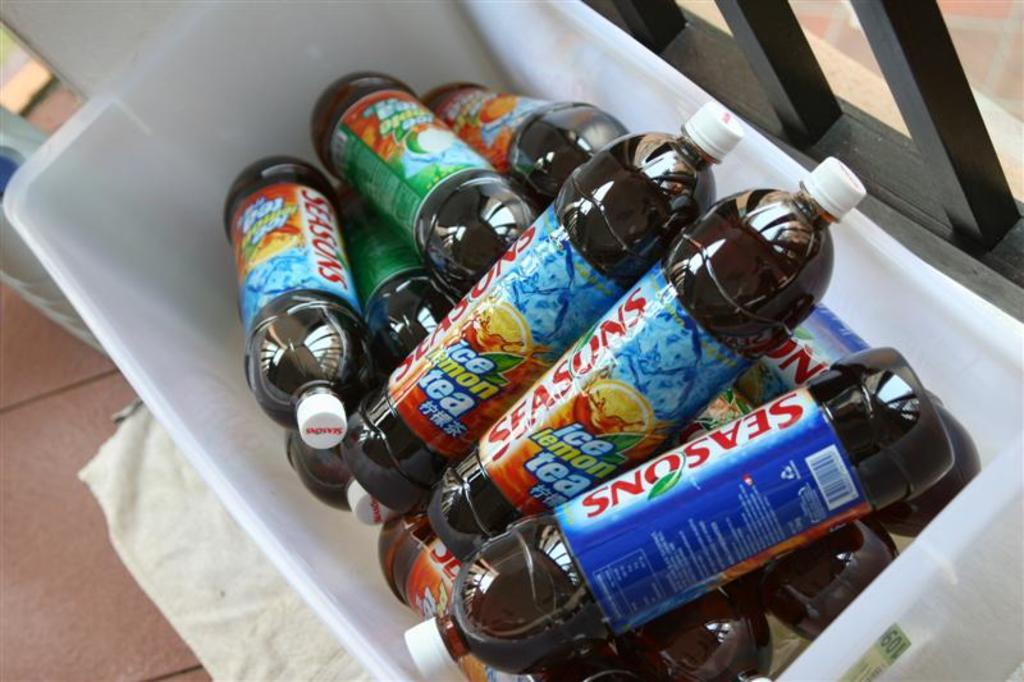<image>
Give a short and clear explanation of the subsequent image. Case full of seasonus drinks that are in a cooler 